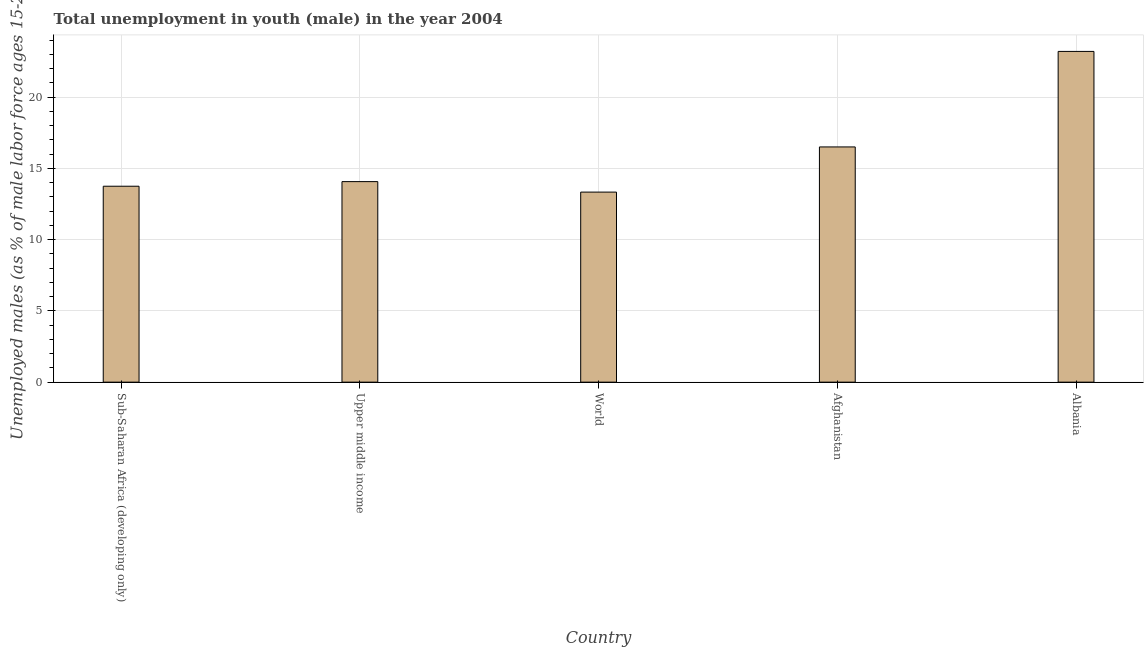Does the graph contain any zero values?
Give a very brief answer. No. What is the title of the graph?
Your answer should be very brief. Total unemployment in youth (male) in the year 2004. What is the label or title of the X-axis?
Offer a very short reply. Country. What is the label or title of the Y-axis?
Your response must be concise. Unemployed males (as % of male labor force ages 15-24). What is the unemployed male youth population in Afghanistan?
Provide a succinct answer. 16.5. Across all countries, what is the maximum unemployed male youth population?
Keep it short and to the point. 23.2. Across all countries, what is the minimum unemployed male youth population?
Ensure brevity in your answer.  13.33. In which country was the unemployed male youth population maximum?
Offer a terse response. Albania. What is the sum of the unemployed male youth population?
Provide a succinct answer. 80.84. What is the difference between the unemployed male youth population in Upper middle income and World?
Keep it short and to the point. 0.73. What is the average unemployed male youth population per country?
Make the answer very short. 16.17. What is the median unemployed male youth population?
Your answer should be very brief. 14.07. In how many countries, is the unemployed male youth population greater than 5 %?
Offer a terse response. 5. What is the ratio of the unemployed male youth population in Upper middle income to that in World?
Your answer should be very brief. 1.05. Is the unemployed male youth population in Albania less than that in World?
Provide a succinct answer. No. Is the difference between the unemployed male youth population in Afghanistan and Albania greater than the difference between any two countries?
Offer a terse response. No. What is the difference between the highest and the second highest unemployed male youth population?
Ensure brevity in your answer.  6.7. What is the difference between the highest and the lowest unemployed male youth population?
Your answer should be very brief. 9.87. In how many countries, is the unemployed male youth population greater than the average unemployed male youth population taken over all countries?
Your answer should be compact. 2. Are all the bars in the graph horizontal?
Offer a very short reply. No. How many countries are there in the graph?
Provide a short and direct response. 5. What is the Unemployed males (as % of male labor force ages 15-24) in Sub-Saharan Africa (developing only)?
Provide a succinct answer. 13.74. What is the Unemployed males (as % of male labor force ages 15-24) in Upper middle income?
Make the answer very short. 14.07. What is the Unemployed males (as % of male labor force ages 15-24) in World?
Offer a terse response. 13.33. What is the Unemployed males (as % of male labor force ages 15-24) in Albania?
Give a very brief answer. 23.2. What is the difference between the Unemployed males (as % of male labor force ages 15-24) in Sub-Saharan Africa (developing only) and Upper middle income?
Make the answer very short. -0.32. What is the difference between the Unemployed males (as % of male labor force ages 15-24) in Sub-Saharan Africa (developing only) and World?
Ensure brevity in your answer.  0.41. What is the difference between the Unemployed males (as % of male labor force ages 15-24) in Sub-Saharan Africa (developing only) and Afghanistan?
Provide a succinct answer. -2.76. What is the difference between the Unemployed males (as % of male labor force ages 15-24) in Sub-Saharan Africa (developing only) and Albania?
Your answer should be compact. -9.46. What is the difference between the Unemployed males (as % of male labor force ages 15-24) in Upper middle income and World?
Keep it short and to the point. 0.73. What is the difference between the Unemployed males (as % of male labor force ages 15-24) in Upper middle income and Afghanistan?
Offer a terse response. -2.43. What is the difference between the Unemployed males (as % of male labor force ages 15-24) in Upper middle income and Albania?
Offer a terse response. -9.13. What is the difference between the Unemployed males (as % of male labor force ages 15-24) in World and Afghanistan?
Your response must be concise. -3.17. What is the difference between the Unemployed males (as % of male labor force ages 15-24) in World and Albania?
Make the answer very short. -9.87. What is the ratio of the Unemployed males (as % of male labor force ages 15-24) in Sub-Saharan Africa (developing only) to that in Upper middle income?
Keep it short and to the point. 0.98. What is the ratio of the Unemployed males (as % of male labor force ages 15-24) in Sub-Saharan Africa (developing only) to that in World?
Provide a succinct answer. 1.03. What is the ratio of the Unemployed males (as % of male labor force ages 15-24) in Sub-Saharan Africa (developing only) to that in Afghanistan?
Provide a short and direct response. 0.83. What is the ratio of the Unemployed males (as % of male labor force ages 15-24) in Sub-Saharan Africa (developing only) to that in Albania?
Your response must be concise. 0.59. What is the ratio of the Unemployed males (as % of male labor force ages 15-24) in Upper middle income to that in World?
Make the answer very short. 1.05. What is the ratio of the Unemployed males (as % of male labor force ages 15-24) in Upper middle income to that in Afghanistan?
Offer a terse response. 0.85. What is the ratio of the Unemployed males (as % of male labor force ages 15-24) in Upper middle income to that in Albania?
Give a very brief answer. 0.61. What is the ratio of the Unemployed males (as % of male labor force ages 15-24) in World to that in Afghanistan?
Keep it short and to the point. 0.81. What is the ratio of the Unemployed males (as % of male labor force ages 15-24) in World to that in Albania?
Make the answer very short. 0.57. What is the ratio of the Unemployed males (as % of male labor force ages 15-24) in Afghanistan to that in Albania?
Offer a very short reply. 0.71. 